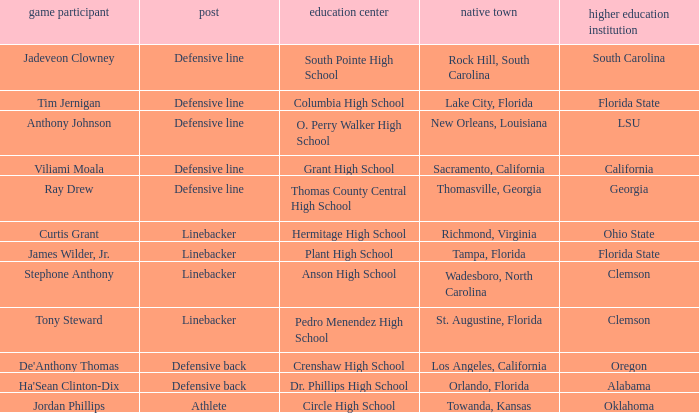Which hometown has a player of Ray Drew? Thomasville, Georgia. 